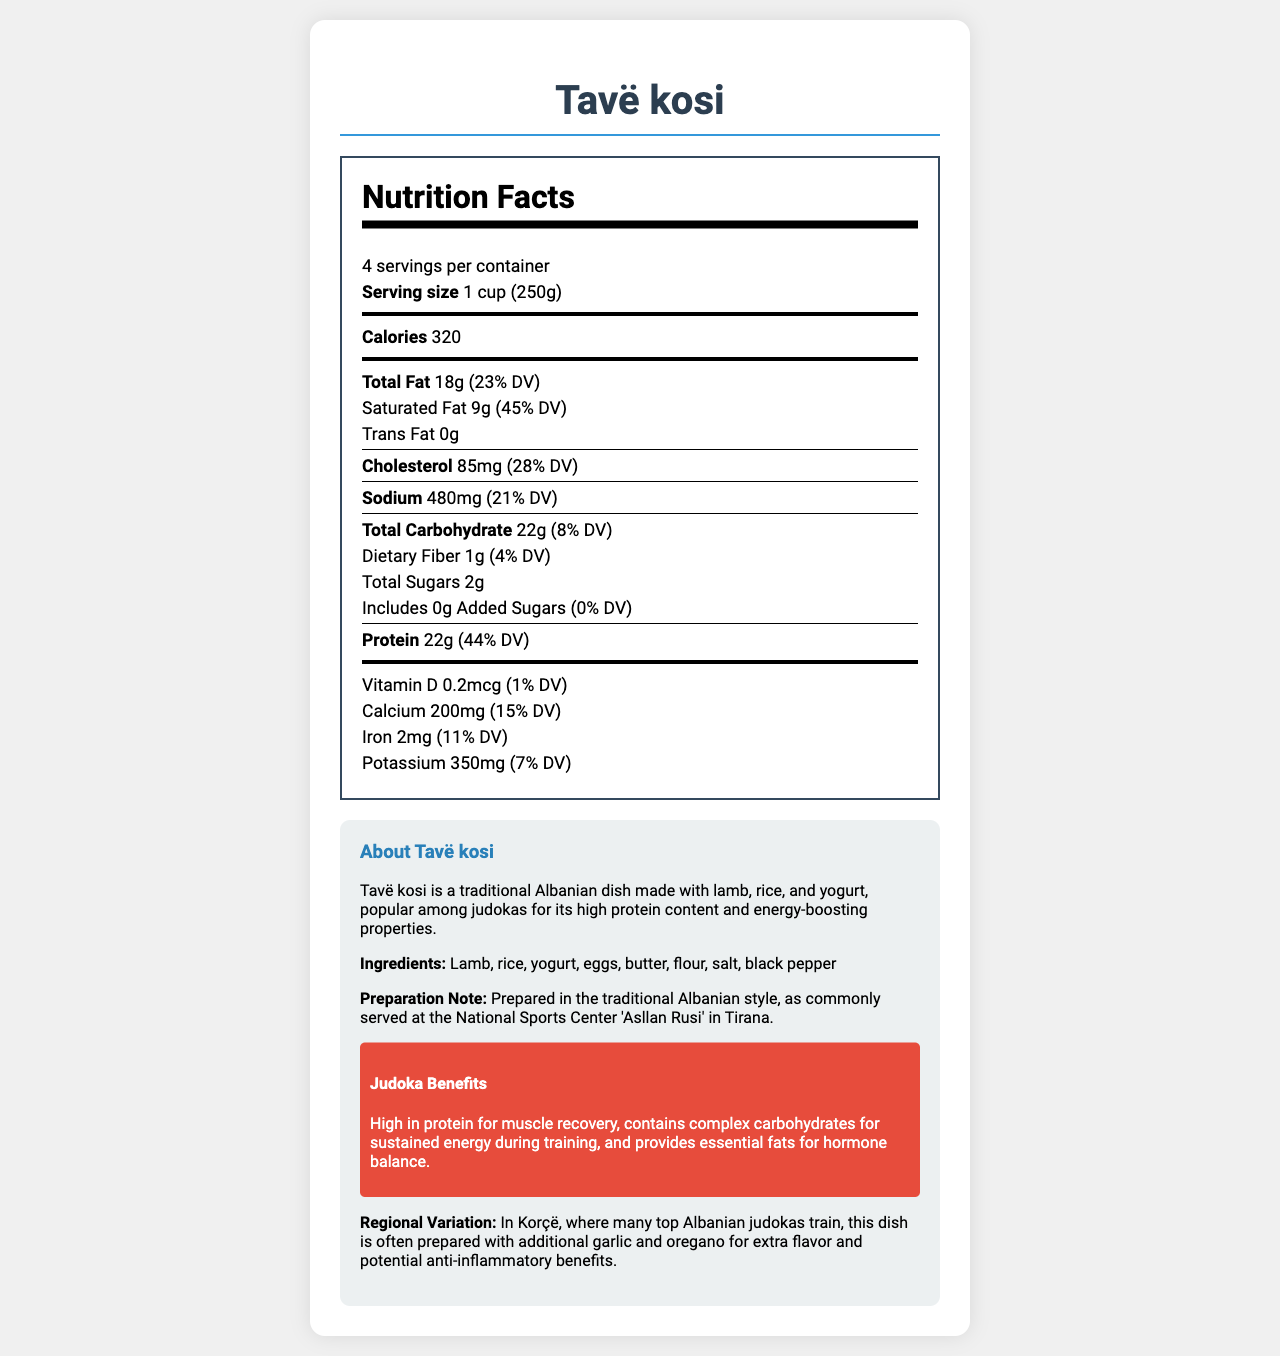what is the serving size of Tavë kosi? The serving size is mentioned directly under the "Serving size" heading in the nutrition facts section of the document.
Answer: 1 cup (250g) how many servings are there per container? The number of servings per container is stated as "4 servings per container" in the nutrition facts section.
Answer: 4 what is the amount of protein per serving? Under the "Protein" heading in the nutrition facts, it states there are 22 grams of protein per serving.
Answer: 22g how much does the total saturated fat contribute to the daily value percentage? The saturated fat content contributing to the daily value is given as 45% in the nutrition facts.
Answer: 45% how many grams of dietary fiber does Tavë kosi contain per serving? The dietary fiber content per serving is listed as 1 gram in the nutrition facts section.
Answer: 1g How much calcium is in a serving of Tavë kosi? The calcium content is listed as 200mg per serving in the nutrition facts section.
Answer: 200mg what percentage of daily value is contributed by cholesterol per serving? The daily value percentage for cholesterol per serving is given as 28% in the nutrition facts section.
Answer: 28% describe why Tavë kosi is beneficial for judokas based on the document. These points are mentioned under the "Judoka Benefits" section in the additional information.
Answer: The dish is high in protein for muscle recovery, it contains complex carbohydrates for sustained energy, and provides essential fats for hormone balance. List the ingredients of Tavë kosi. The ingredients are clearly stated under the "Ingredients" heading in the additional information.
Answer: Lamb, rice, yogurt, eggs, butter, flour, salt, black pepper How does the regional variation in Korçë enhance Tavë kosi? This information is provided under the "Regional Variation" section in the additional information.
Answer: It is prepared with additional garlic and oregano for extra flavor and potential anti-inflammatory benefits. How many calories are in one serving of Tavë kosi? The calories per serving are mentioned directly in the nutrition facts section as 320 calories.
Answer: 320 calories What is the sodium content per serving? The sodium content per serving is listed as 480mg in the nutrition facts.
Answer: 480mg Which nutrient has the highest daily value percentage per serving? A. Saturated Fat B. Sodium C. Protein D. Cholesterol Saturated fat has a daily value percentage of 45%, which is the highest among the listed nutrients in the nutrition facts.
Answer: A. Saturated Fat What is the main source of protein in Tavë kosi? A. Eggs B. Lamb C. Yogurt Lamb is the primary ingredient contributing to the high protein content, as inferred from the ingredient list which includes lamb.
Answer: B. Lamb Is Tavë kosi a good source of Vitamin D? The vitamin D content is very low, at 0.2 mcg (1% daily value), indicating it is not a significant source of Vitamin D.
Answer: No Summarize the nutrition and benefits of Tavë kosi for a judoka. The summary integrates information from both the nutrition facts and the additional information sections highlighting the dish’s benefits for judokas.
Answer: Tavë kosi, a traditional Albanian dish made with lamb, rice, and yogurt, offers a high protein content of 22g per serving which is beneficial for muscle recovery. It also includes complex carbohydrates for sustained energy and essential fats for hormone balance. Containing 320 calories per serving, it combines various nutrients like calcium (15% DV) and iron (11% DV), making it a balanced meal for athletes. What is the preparation time for Tavë kosi? The document does not provide any details regarding the preparation time, making it impossible to answer this question based on the visual information provided.
Answer: Not enough information 